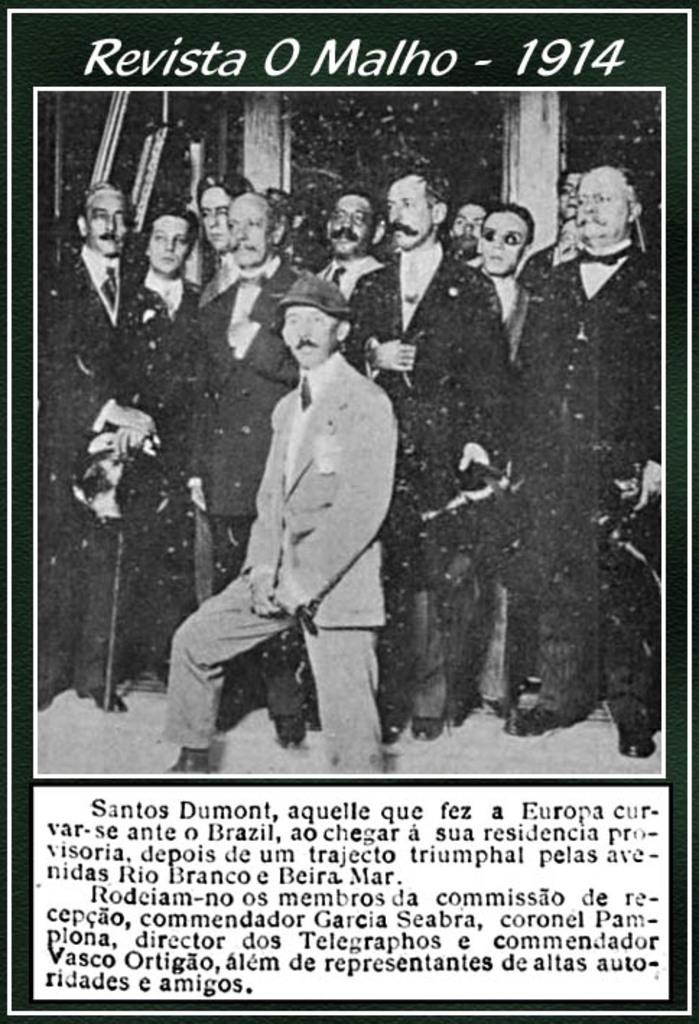What is featured in the image? There is a poster in the image. What can be seen on the poster? The poster includes people standing. Are there any words or letters on the poster? Yes, there is text written on the poster. How many tomatoes are on the road in the image? There are no tomatoes or roads present in the image; it only features a poster with people standing and text. 